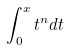Convert formula to latex. <formula><loc_0><loc_0><loc_500><loc_500>\int _ { 0 } ^ { x } t ^ { n } d t</formula> 